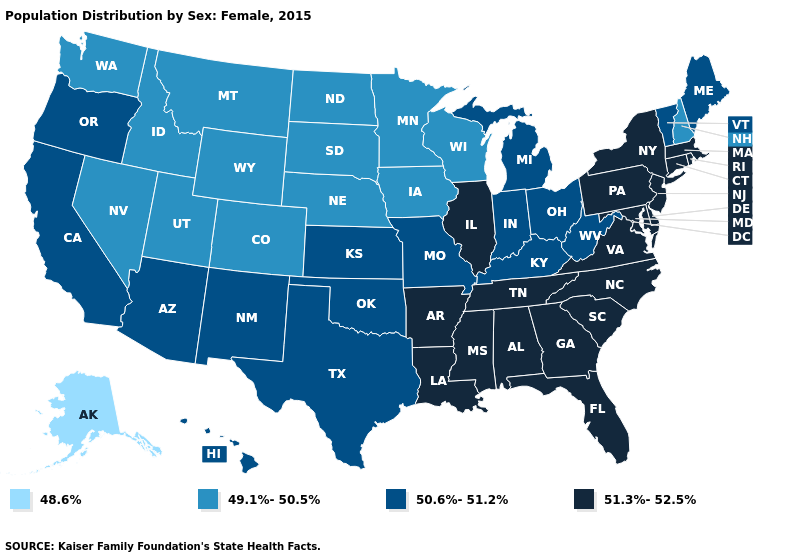Name the states that have a value in the range 50.6%-51.2%?
Give a very brief answer. Arizona, California, Hawaii, Indiana, Kansas, Kentucky, Maine, Michigan, Missouri, New Mexico, Ohio, Oklahoma, Oregon, Texas, Vermont, West Virginia. Does the map have missing data?
Answer briefly. No. What is the value of Louisiana?
Short answer required. 51.3%-52.5%. Does Arkansas have the same value as Kentucky?
Keep it brief. No. What is the value of Washington?
Quick response, please. 49.1%-50.5%. Does Michigan have the same value as Kansas?
Give a very brief answer. Yes. What is the value of Hawaii?
Concise answer only. 50.6%-51.2%. Among the states that border New Mexico , does Texas have the highest value?
Write a very short answer. Yes. What is the highest value in states that border New York?
Concise answer only. 51.3%-52.5%. Name the states that have a value in the range 48.6%?
Be succinct. Alaska. Does the first symbol in the legend represent the smallest category?
Keep it brief. Yes. What is the lowest value in states that border Ohio?
Write a very short answer. 50.6%-51.2%. Does the map have missing data?
Be succinct. No. Name the states that have a value in the range 48.6%?
Give a very brief answer. Alaska. 